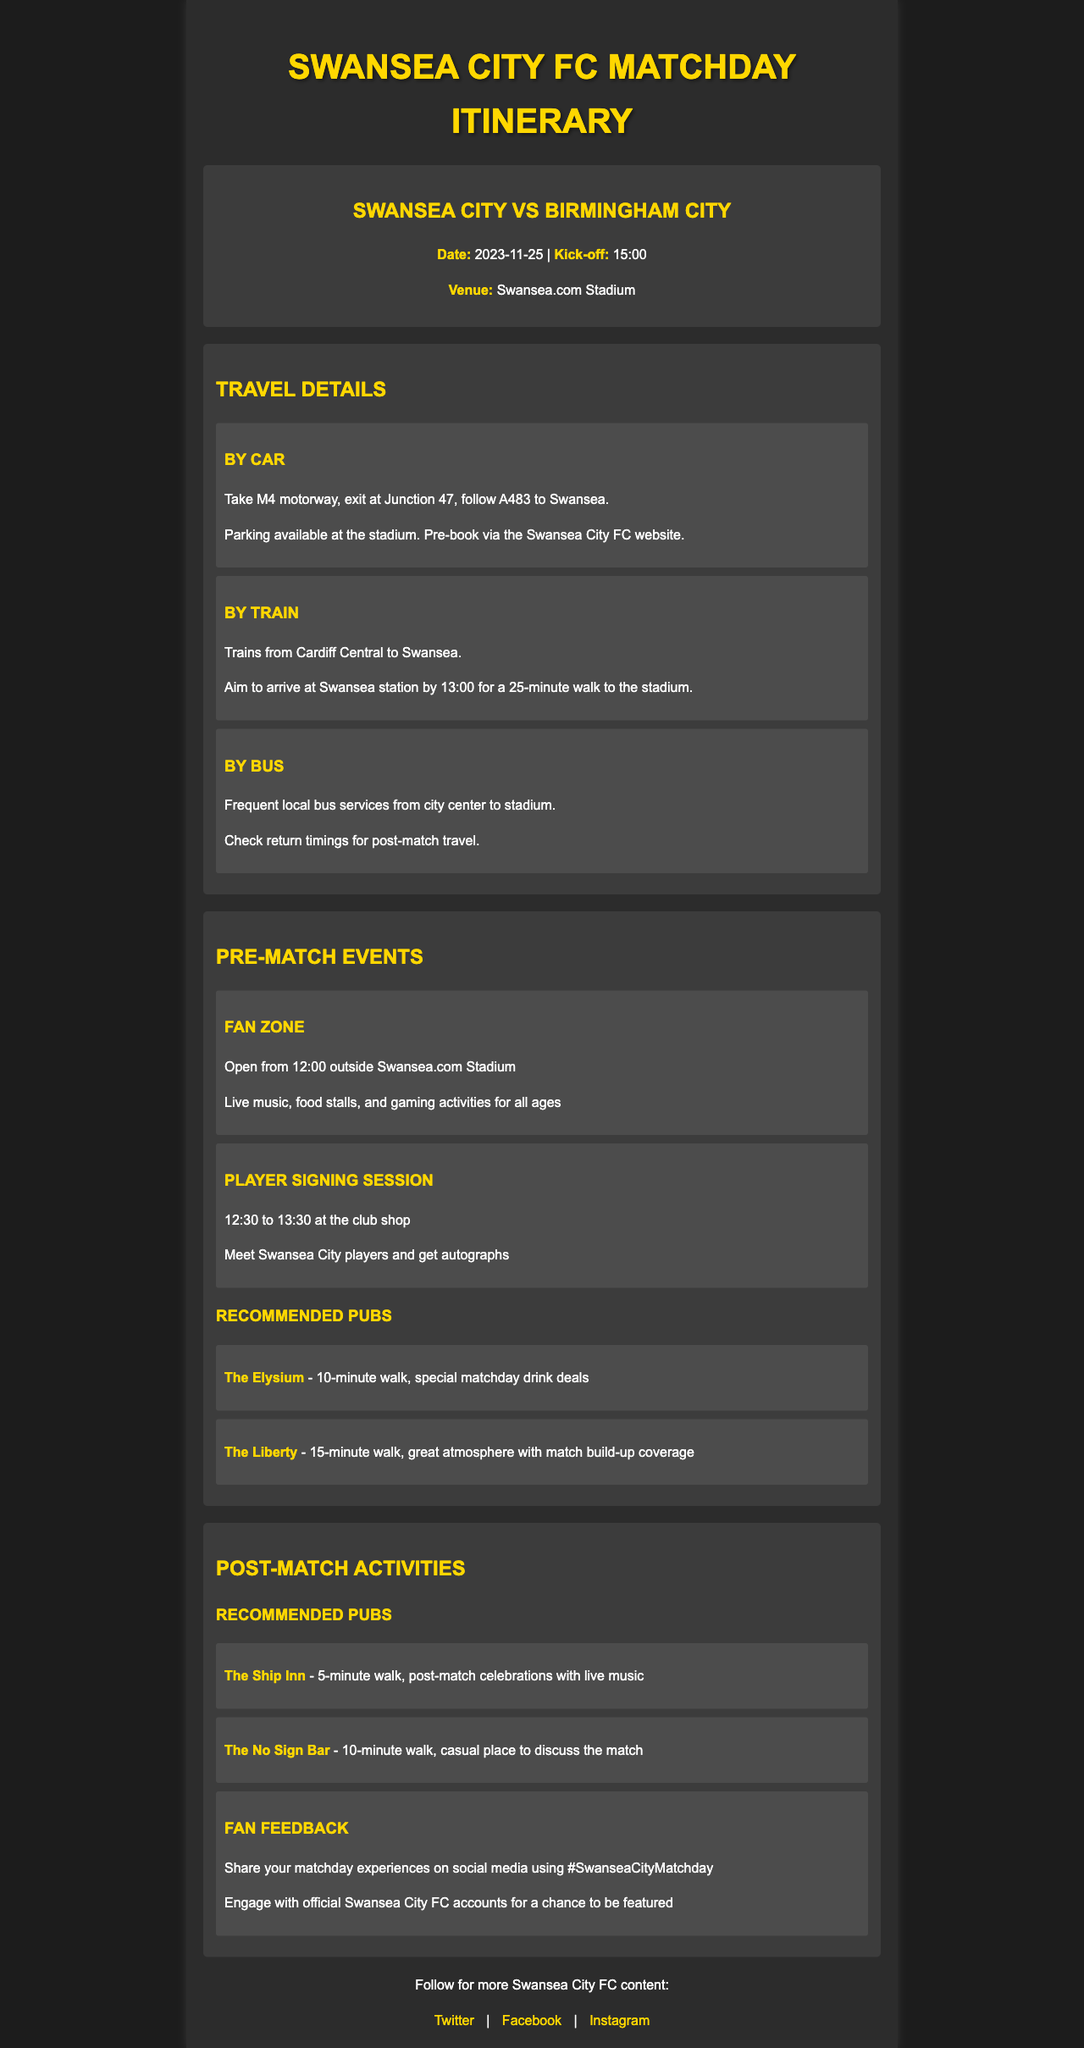What is the date of the match? The date of the match is clearly stated in the match info section of the document.
Answer: 2023-11-25 What time does the match kick-off? The kick-off time is explicitly mentioned in the match info section of the document.
Answer: 15:00 What is the venue for the match? The venue is indicated in the match info section of the document.
Answer: Swansea.com Stadium What are the names of the recommended pubs before the match? The names of the recommended pubs are provided in the pre-match section of the document.
Answer: The Elysium, The Liberty What time does the Fan Zone open? The opening time for the Fan Zone is given in the pre-match events section.
Answer: 12:00 How long should fans aim to arrive at the Swansea station before the match? The suggested arrival time at the station is mentioned in the travel option information within the document.
Answer: 13:00 What is the walking distance from The Ship Inn to the stadium? The walking distance is listed in the post-match activities section where the pubs are mentioned.
Answer: 5-minute walk What hashtag can fans use to share their matchday experiences? The document provides a specific hashtag for fans to use in the fan feedback section.
Answer: #SwanseaCityMatchday How long does the player signing session last? The duration of the player signing session is specified in the pre-match events section.
Answer: 1 hour 